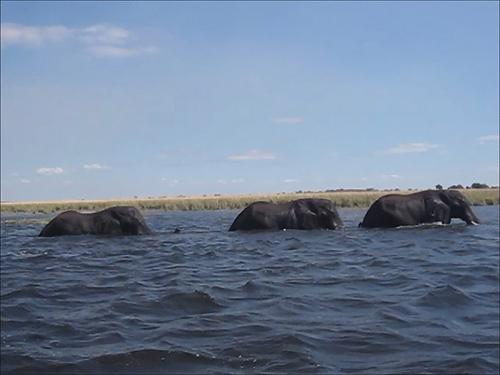Question: what are pictured?
Choices:
A. Elephants.
B. Donkeys.
C. Giraffe.
D. Horses.
Answer with the letter. Answer: A Question: why was the photo taken?
Choices:
A. For the newspaper.
B. As a memory.
C. For proof of action.
D. For a magazine.
Answer with the letter. Answer: D Question: what is in the distance?
Choices:
A. Dry land.
B. Trees.
C. Grass.
D. Helicopter.
Answer with the letter. Answer: A 